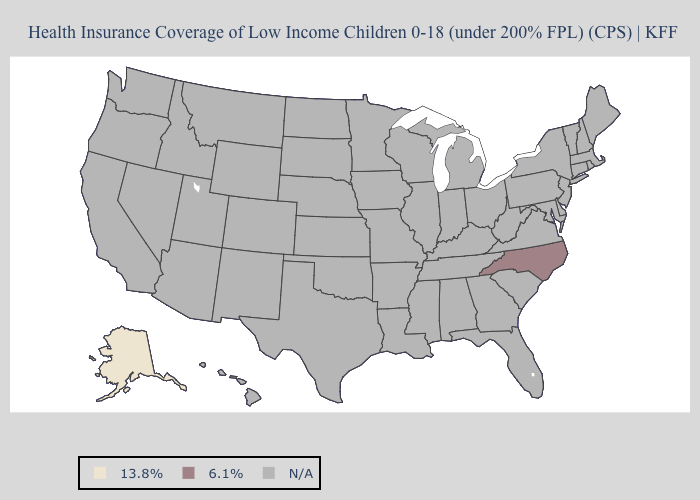Name the states that have a value in the range N/A?
Keep it brief. Alabama, Arizona, Arkansas, California, Colorado, Connecticut, Delaware, Florida, Georgia, Hawaii, Idaho, Illinois, Indiana, Iowa, Kansas, Kentucky, Louisiana, Maine, Maryland, Massachusetts, Michigan, Minnesota, Mississippi, Missouri, Montana, Nebraska, Nevada, New Hampshire, New Jersey, New Mexico, New York, North Dakota, Ohio, Oklahoma, Oregon, Pennsylvania, Rhode Island, South Carolina, South Dakota, Tennessee, Texas, Utah, Vermont, Virginia, Washington, West Virginia, Wisconsin, Wyoming. Name the states that have a value in the range 13.8%?
Keep it brief. Alaska. What is the value of Arkansas?
Give a very brief answer. N/A. Name the states that have a value in the range 6.1%?
Give a very brief answer. North Carolina. What is the value of Rhode Island?
Be succinct. N/A. Name the states that have a value in the range 6.1%?
Short answer required. North Carolina. Name the states that have a value in the range N/A?
Be succinct. Alabama, Arizona, Arkansas, California, Colorado, Connecticut, Delaware, Florida, Georgia, Hawaii, Idaho, Illinois, Indiana, Iowa, Kansas, Kentucky, Louisiana, Maine, Maryland, Massachusetts, Michigan, Minnesota, Mississippi, Missouri, Montana, Nebraska, Nevada, New Hampshire, New Jersey, New Mexico, New York, North Dakota, Ohio, Oklahoma, Oregon, Pennsylvania, Rhode Island, South Carolina, South Dakota, Tennessee, Texas, Utah, Vermont, Virginia, Washington, West Virginia, Wisconsin, Wyoming. What is the highest value in the USA?
Answer briefly. 6.1%. What is the value of Oregon?
Write a very short answer. N/A. Which states hav the highest value in the South?
Concise answer only. North Carolina. What is the lowest value in the USA?
Be succinct. 13.8%. What is the value of Alabama?
Concise answer only. N/A. 